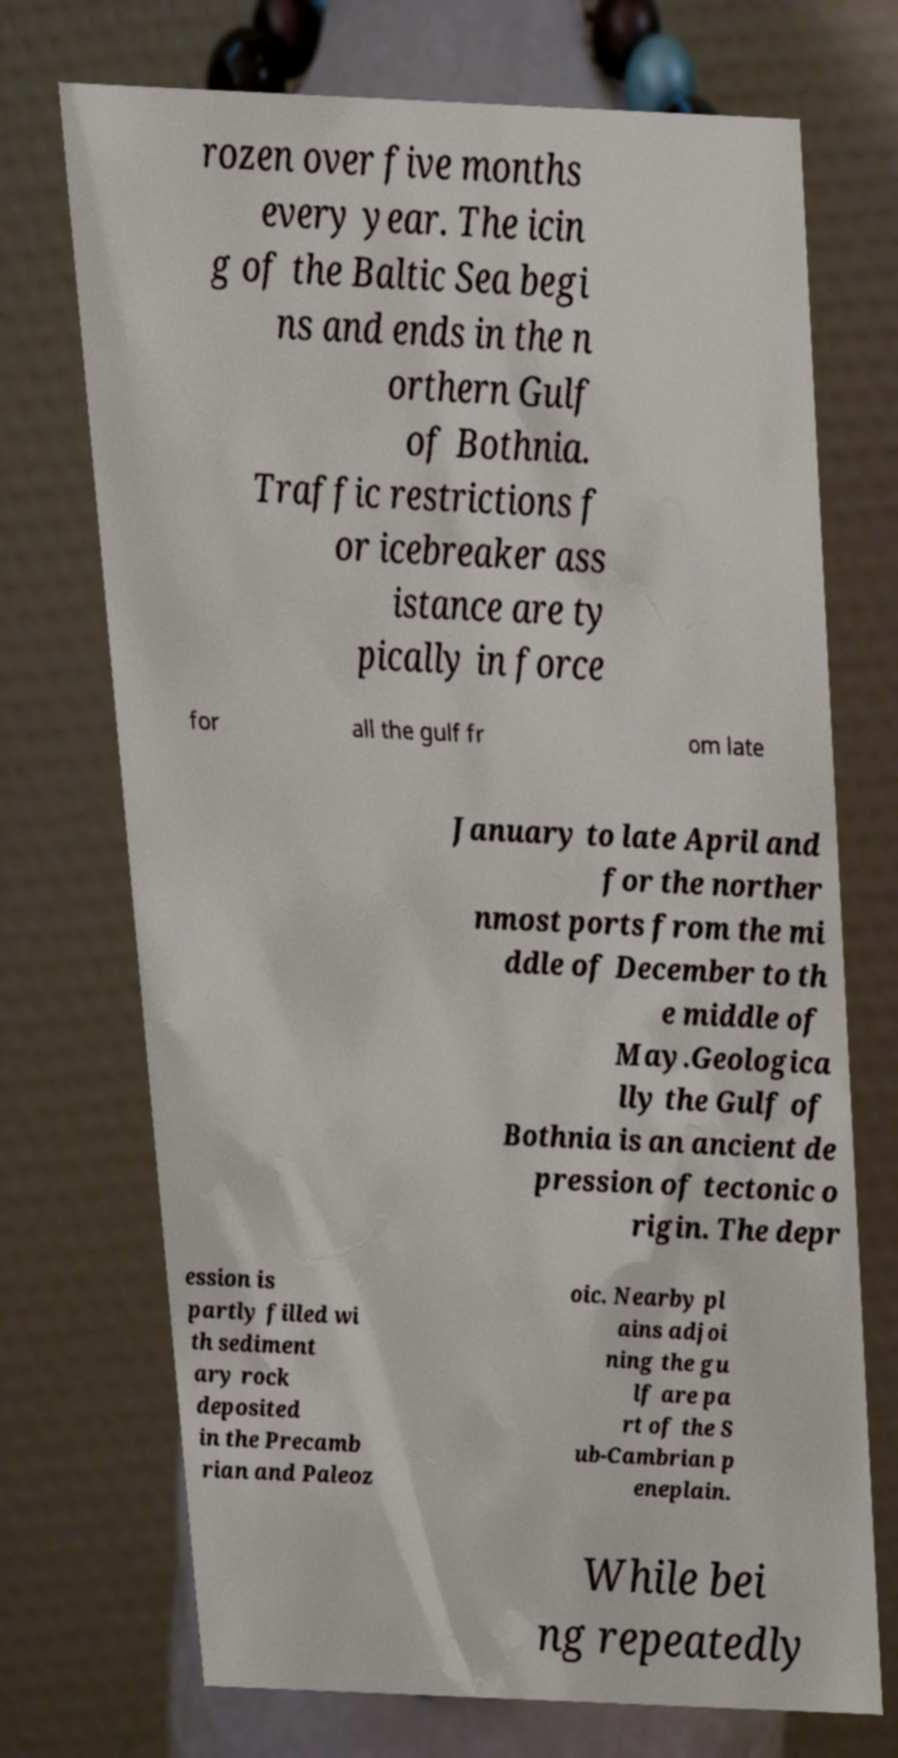Please read and relay the text visible in this image. What does it say? rozen over five months every year. The icin g of the Baltic Sea begi ns and ends in the n orthern Gulf of Bothnia. Traffic restrictions f or icebreaker ass istance are ty pically in force for all the gulf fr om late January to late April and for the norther nmost ports from the mi ddle of December to th e middle of May.Geologica lly the Gulf of Bothnia is an ancient de pression of tectonic o rigin. The depr ession is partly filled wi th sediment ary rock deposited in the Precamb rian and Paleoz oic. Nearby pl ains adjoi ning the gu lf are pa rt of the S ub-Cambrian p eneplain. While bei ng repeatedly 